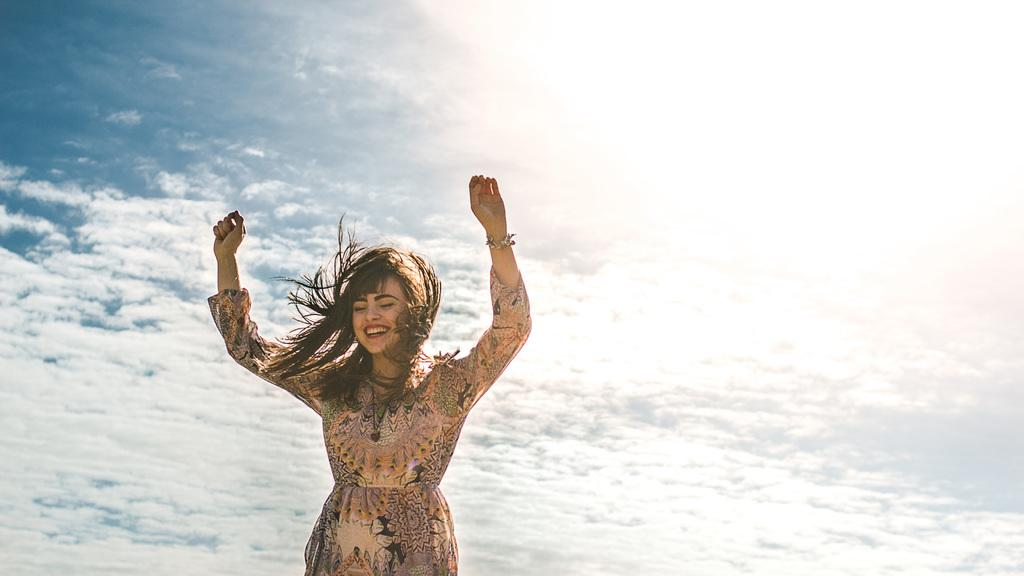Who is the main subject in the image? There is a woman in the image. What can be said about the woman's appearance? The woman has long hair and is wearing a dress. How is the woman described? The woman is described as stunning. What is visible in the background of the image? There is a cloudy sky in the background of the image. What type of insect is crawling on the woman's tongue in the image? There is no insect present on the woman's tongue in the image. 